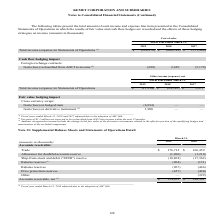From Kemet Corporation's financial document, Which years does the table provide information for the Supplemental Balance Sheets and Statements of Operations Detail for the company? The document shows two values: 2019 and 2018. From the document: "(amounts in thousands) 2019 2018 (amounts in thousands) 2019 2018..." Also, What was the amount of trade in 2019? According to the financial document, 176,715 (in thousands). The relevant text states: "Trade $ 176,715 $ 166,459..." Also, What was the Allowance for doubtful accounts reserve in 2018? According to the financial document, (1,210) (in thousands). The relevant text states: "Allowance for doubtful accounts reserve (1,206) (1,210)..." Also, Which years did the net accounts receivables exceed $150,000 thousand? Based on the analysis, there are 1 instances. The counting process: 2019. Also, can you calculate: What was the change in the Returns reserves between 2018 and 2019? Based on the calculation: -964-(-131), the result is -833 (in thousands). This is based on the information: "Returns reserves (1) (964) (131) Returns reserves (1) (964) (131)..." The key data points involved are: 131, 964. Also, can you calculate: What was the percentage change in the amount of trade between 2018 and 2019? To answer this question, I need to perform calculations using the financial data. The calculation is: (176,715-166,459)/166,459, which equals 6.16 (percentage). This is based on the information: "Trade $ 176,715 $ 166,459 Trade $ 176,715 $ 166,459..." The key data points involved are: 166,459, 176,715. 